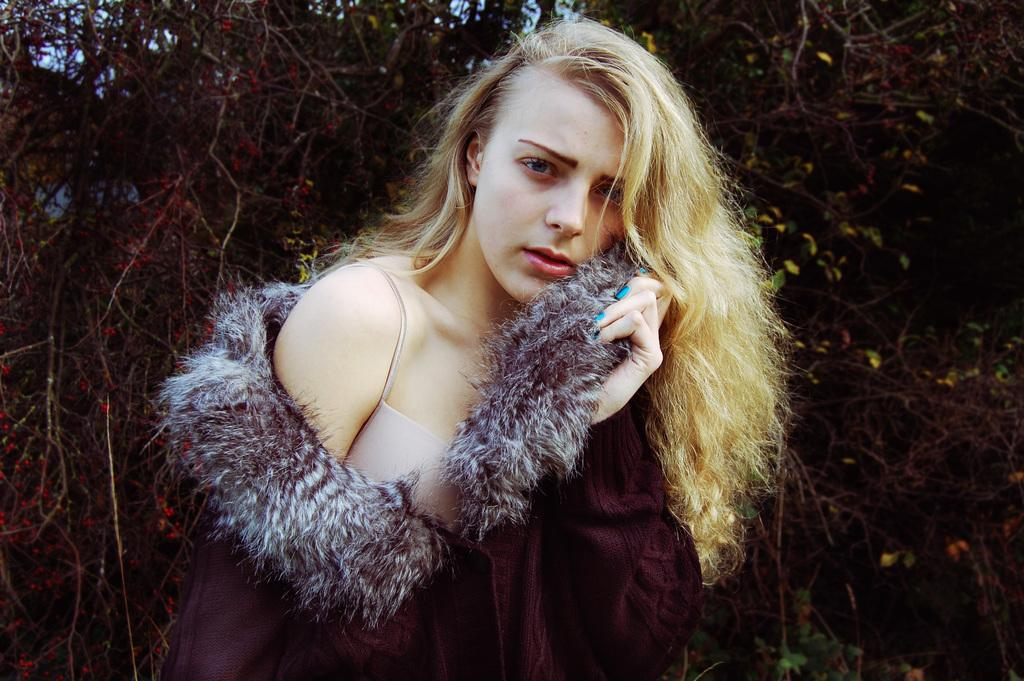Who is the main subject in the image? There is a girl in the center of the image. What is the girl wearing? The girl is wearing a jacket. What can be seen in the background of the image? There are trees in the background of the image. What type of laborer can be seen in the image? There is no laborer present in the image. 